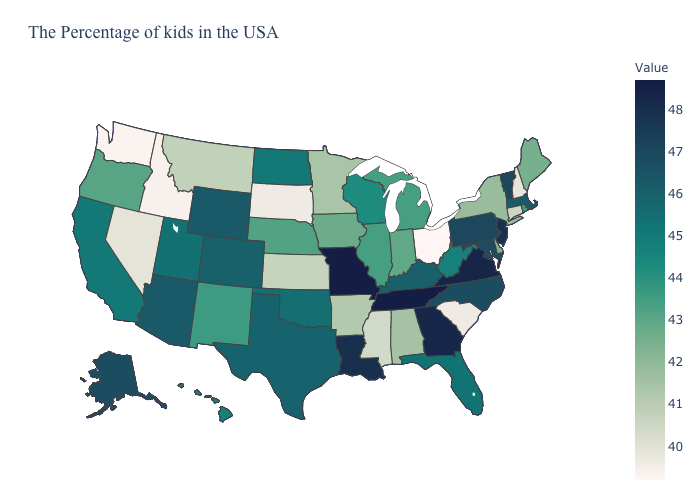Does New York have the lowest value in the USA?
Write a very short answer. No. Among the states that border New Jersey , which have the highest value?
Concise answer only. Pennsylvania. Is the legend a continuous bar?
Concise answer only. Yes. Does New Jersey have the highest value in the Northeast?
Be succinct. Yes. Does Missouri have the highest value in the MidWest?
Quick response, please. Yes. Among the states that border Minnesota , which have the highest value?
Concise answer only. North Dakota. Among the states that border New Hampshire , does Vermont have the highest value?
Keep it brief. Yes. 